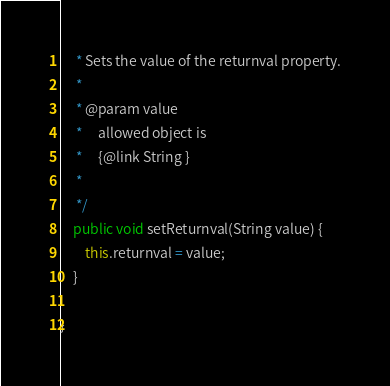Convert code to text. <code><loc_0><loc_0><loc_500><loc_500><_Java_>     * Sets the value of the returnval property.
     * 
     * @param value
     *     allowed object is
     *     {@link String }
     *     
     */
    public void setReturnval(String value) {
        this.returnval = value;
    }

}
</code> 